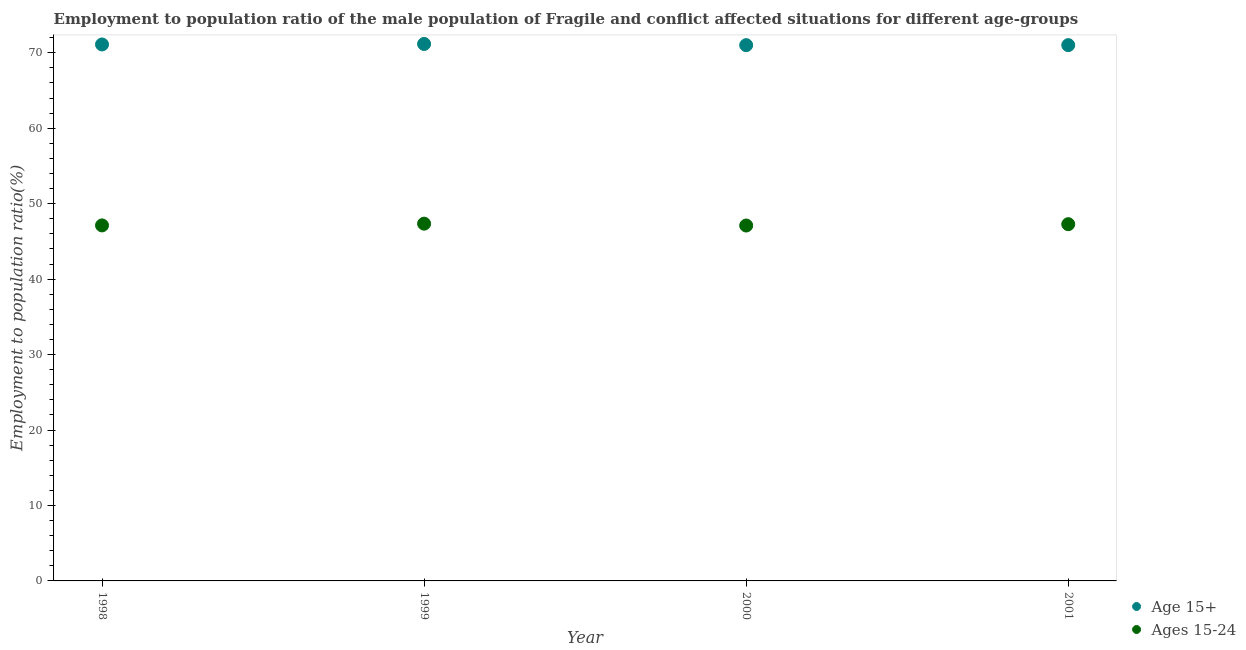Is the number of dotlines equal to the number of legend labels?
Provide a succinct answer. Yes. What is the employment to population ratio(age 15+) in 2001?
Provide a succinct answer. 71.01. Across all years, what is the maximum employment to population ratio(age 15+)?
Ensure brevity in your answer.  71.17. Across all years, what is the minimum employment to population ratio(age 15-24)?
Make the answer very short. 47.1. What is the total employment to population ratio(age 15+) in the graph?
Provide a succinct answer. 284.3. What is the difference between the employment to population ratio(age 15-24) in 1999 and that in 2001?
Give a very brief answer. 0.07. What is the difference between the employment to population ratio(age 15+) in 2001 and the employment to population ratio(age 15-24) in 1998?
Your answer should be compact. 23.89. What is the average employment to population ratio(age 15+) per year?
Keep it short and to the point. 71.07. In the year 2000, what is the difference between the employment to population ratio(age 15+) and employment to population ratio(age 15-24)?
Provide a succinct answer. 23.91. In how many years, is the employment to population ratio(age 15+) greater than 70 %?
Your answer should be very brief. 4. What is the ratio of the employment to population ratio(age 15-24) in 1999 to that in 2000?
Give a very brief answer. 1.01. Is the difference between the employment to population ratio(age 15+) in 1999 and 2000 greater than the difference between the employment to population ratio(age 15-24) in 1999 and 2000?
Your answer should be compact. No. What is the difference between the highest and the second highest employment to population ratio(age 15+)?
Offer a terse response. 0.07. What is the difference between the highest and the lowest employment to population ratio(age 15-24)?
Make the answer very short. 0.25. In how many years, is the employment to population ratio(age 15+) greater than the average employment to population ratio(age 15+) taken over all years?
Provide a succinct answer. 2. Is the sum of the employment to population ratio(age 15-24) in 2000 and 2001 greater than the maximum employment to population ratio(age 15+) across all years?
Your response must be concise. Yes. Is the employment to population ratio(age 15+) strictly less than the employment to population ratio(age 15-24) over the years?
Offer a terse response. No. How many years are there in the graph?
Make the answer very short. 4. How many legend labels are there?
Your answer should be very brief. 2. How are the legend labels stacked?
Give a very brief answer. Vertical. What is the title of the graph?
Your answer should be compact. Employment to population ratio of the male population of Fragile and conflict affected situations for different age-groups. What is the label or title of the X-axis?
Offer a very short reply. Year. What is the label or title of the Y-axis?
Give a very brief answer. Employment to population ratio(%). What is the Employment to population ratio(%) in Age 15+ in 1998?
Your response must be concise. 71.1. What is the Employment to population ratio(%) of Ages 15-24 in 1998?
Make the answer very short. 47.12. What is the Employment to population ratio(%) of Age 15+ in 1999?
Ensure brevity in your answer.  71.17. What is the Employment to population ratio(%) in Ages 15-24 in 1999?
Make the answer very short. 47.35. What is the Employment to population ratio(%) in Age 15+ in 2000?
Your answer should be compact. 71.01. What is the Employment to population ratio(%) in Ages 15-24 in 2000?
Your response must be concise. 47.1. What is the Employment to population ratio(%) in Age 15+ in 2001?
Your response must be concise. 71.01. What is the Employment to population ratio(%) of Ages 15-24 in 2001?
Your answer should be compact. 47.28. Across all years, what is the maximum Employment to population ratio(%) in Age 15+?
Ensure brevity in your answer.  71.17. Across all years, what is the maximum Employment to population ratio(%) of Ages 15-24?
Offer a very short reply. 47.35. Across all years, what is the minimum Employment to population ratio(%) of Age 15+?
Your response must be concise. 71.01. Across all years, what is the minimum Employment to population ratio(%) of Ages 15-24?
Provide a short and direct response. 47.1. What is the total Employment to population ratio(%) in Age 15+ in the graph?
Provide a succinct answer. 284.3. What is the total Employment to population ratio(%) in Ages 15-24 in the graph?
Ensure brevity in your answer.  188.86. What is the difference between the Employment to population ratio(%) of Age 15+ in 1998 and that in 1999?
Keep it short and to the point. -0.07. What is the difference between the Employment to population ratio(%) in Ages 15-24 in 1998 and that in 1999?
Provide a succinct answer. -0.23. What is the difference between the Employment to population ratio(%) of Age 15+ in 1998 and that in 2000?
Offer a very short reply. 0.09. What is the difference between the Employment to population ratio(%) in Ages 15-24 in 1998 and that in 2000?
Keep it short and to the point. 0.02. What is the difference between the Employment to population ratio(%) of Age 15+ in 1998 and that in 2001?
Your response must be concise. 0.09. What is the difference between the Employment to population ratio(%) of Ages 15-24 in 1998 and that in 2001?
Keep it short and to the point. -0.16. What is the difference between the Employment to population ratio(%) in Age 15+ in 1999 and that in 2000?
Keep it short and to the point. 0.16. What is the difference between the Employment to population ratio(%) in Ages 15-24 in 1999 and that in 2000?
Provide a succinct answer. 0.25. What is the difference between the Employment to population ratio(%) in Age 15+ in 1999 and that in 2001?
Give a very brief answer. 0.16. What is the difference between the Employment to population ratio(%) in Ages 15-24 in 1999 and that in 2001?
Offer a terse response. 0.07. What is the difference between the Employment to population ratio(%) in Age 15+ in 2000 and that in 2001?
Your response must be concise. -0. What is the difference between the Employment to population ratio(%) of Ages 15-24 in 2000 and that in 2001?
Provide a succinct answer. -0.18. What is the difference between the Employment to population ratio(%) of Age 15+ in 1998 and the Employment to population ratio(%) of Ages 15-24 in 1999?
Make the answer very short. 23.75. What is the difference between the Employment to population ratio(%) of Age 15+ in 1998 and the Employment to population ratio(%) of Ages 15-24 in 2000?
Give a very brief answer. 24. What is the difference between the Employment to population ratio(%) in Age 15+ in 1998 and the Employment to population ratio(%) in Ages 15-24 in 2001?
Provide a succinct answer. 23.82. What is the difference between the Employment to population ratio(%) of Age 15+ in 1999 and the Employment to population ratio(%) of Ages 15-24 in 2000?
Provide a short and direct response. 24.07. What is the difference between the Employment to population ratio(%) of Age 15+ in 1999 and the Employment to population ratio(%) of Ages 15-24 in 2001?
Your answer should be compact. 23.89. What is the difference between the Employment to population ratio(%) of Age 15+ in 2000 and the Employment to population ratio(%) of Ages 15-24 in 2001?
Provide a short and direct response. 23.73. What is the average Employment to population ratio(%) of Age 15+ per year?
Your answer should be compact. 71.07. What is the average Employment to population ratio(%) in Ages 15-24 per year?
Your response must be concise. 47.21. In the year 1998, what is the difference between the Employment to population ratio(%) in Age 15+ and Employment to population ratio(%) in Ages 15-24?
Offer a terse response. 23.98. In the year 1999, what is the difference between the Employment to population ratio(%) in Age 15+ and Employment to population ratio(%) in Ages 15-24?
Give a very brief answer. 23.82. In the year 2000, what is the difference between the Employment to population ratio(%) of Age 15+ and Employment to population ratio(%) of Ages 15-24?
Provide a succinct answer. 23.91. In the year 2001, what is the difference between the Employment to population ratio(%) of Age 15+ and Employment to population ratio(%) of Ages 15-24?
Make the answer very short. 23.73. What is the ratio of the Employment to population ratio(%) in Age 15+ in 1998 to that in 1999?
Provide a short and direct response. 1. What is the ratio of the Employment to population ratio(%) in Ages 15-24 in 1998 to that in 2000?
Offer a very short reply. 1. What is the ratio of the Employment to population ratio(%) in Age 15+ in 1998 to that in 2001?
Make the answer very short. 1. What is the ratio of the Employment to population ratio(%) of Age 15+ in 1999 to that in 2000?
Your answer should be very brief. 1. What is the ratio of the Employment to population ratio(%) in Ages 15-24 in 2000 to that in 2001?
Your answer should be compact. 1. What is the difference between the highest and the second highest Employment to population ratio(%) of Age 15+?
Ensure brevity in your answer.  0.07. What is the difference between the highest and the second highest Employment to population ratio(%) of Ages 15-24?
Your answer should be very brief. 0.07. What is the difference between the highest and the lowest Employment to population ratio(%) in Age 15+?
Your response must be concise. 0.16. What is the difference between the highest and the lowest Employment to population ratio(%) of Ages 15-24?
Your answer should be compact. 0.25. 